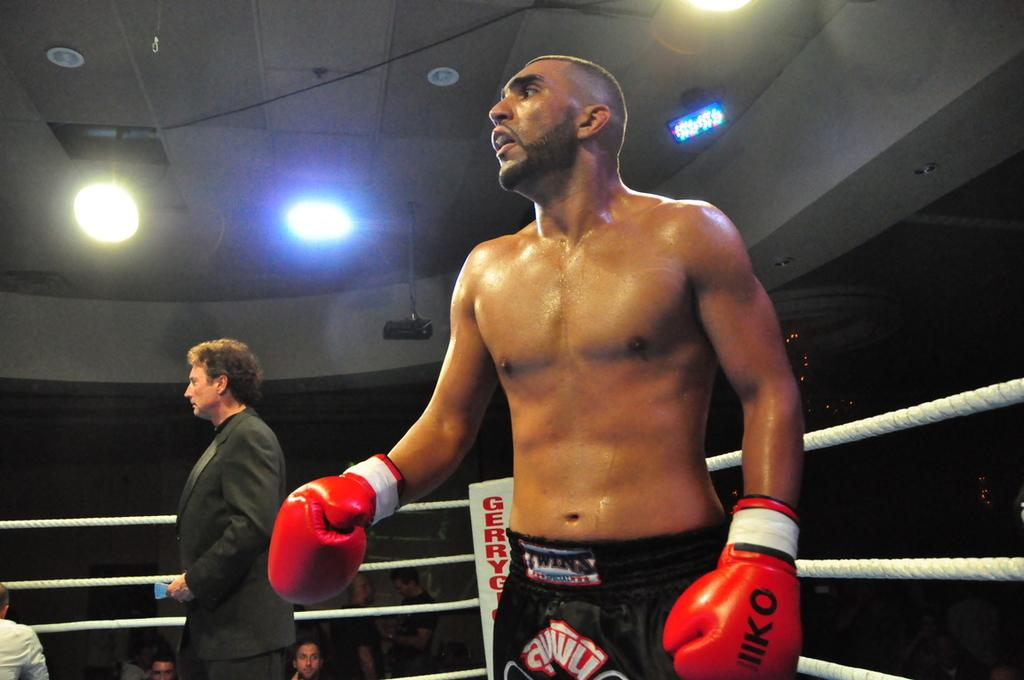What is the main subject of the image? The main subject of the image is a boxing player. Can you describe the setting of the image? The boxing player is surrounded by a fencing with ropes, and there is a man behind the boxing player. What else can be seen in the background of the image? There is a group of people in the background of the image. What type of worm can be seen crawling on the boxing player's gloves in the image? There is no worm present in the image; the boxing player's gloves are not shown to have any worms on them. 